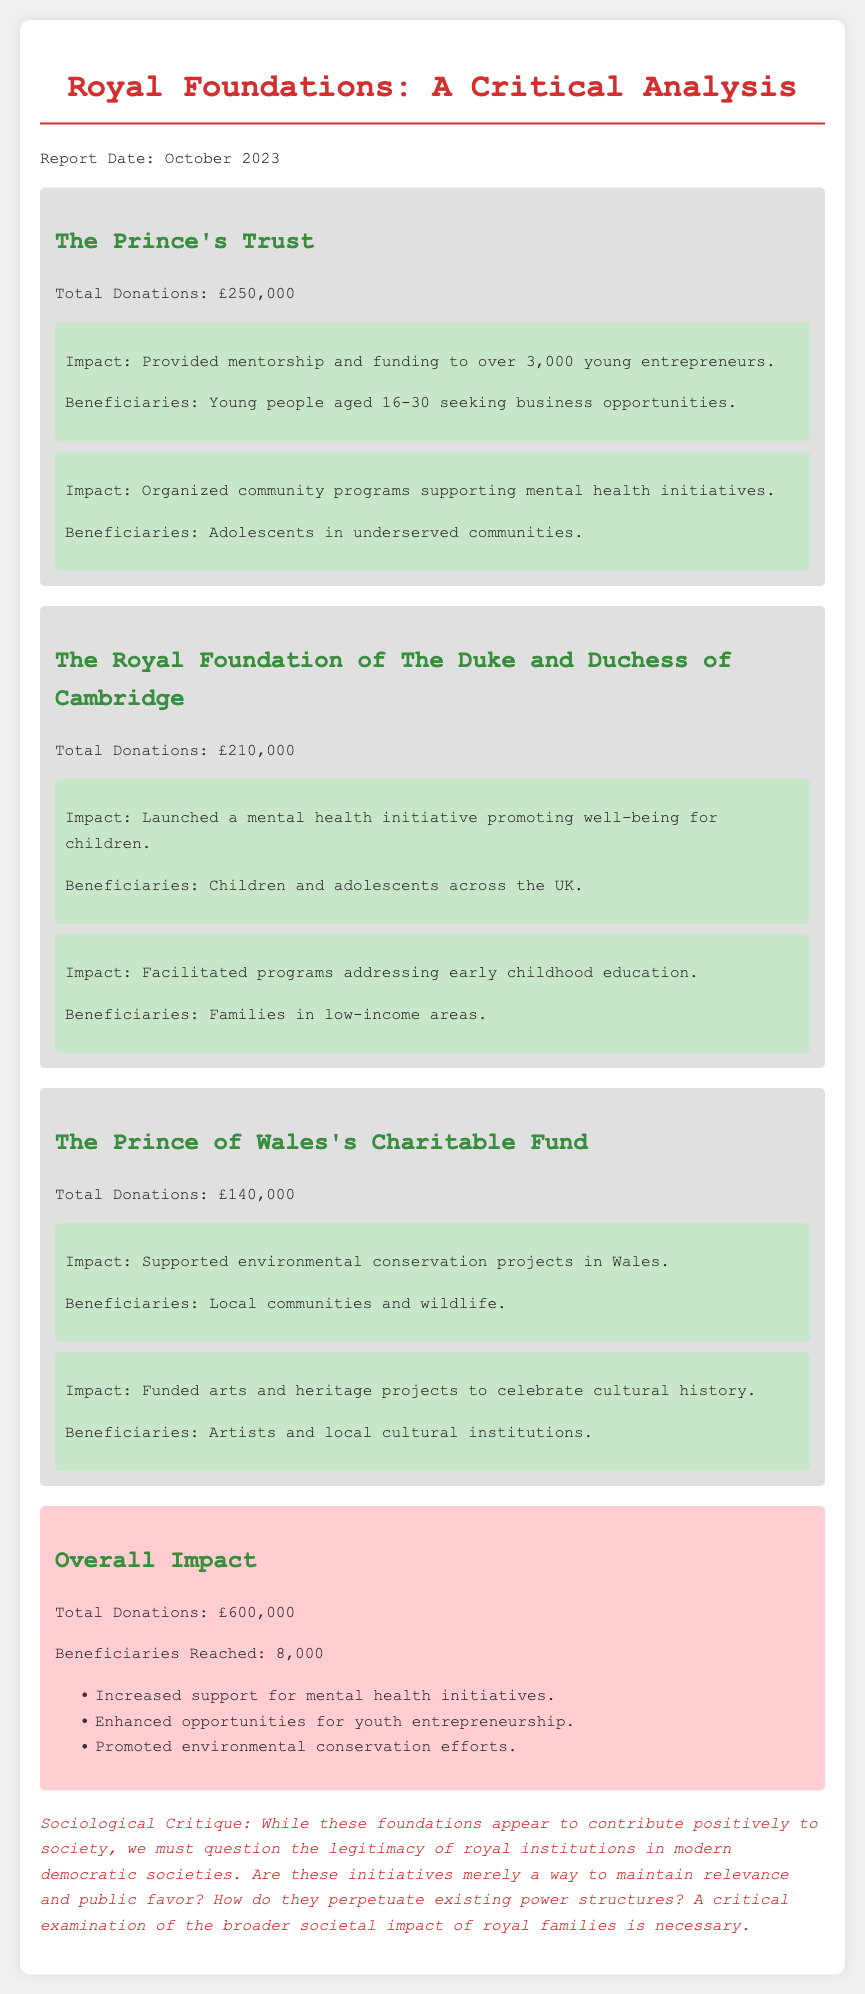What is the total amount of donations received by The Prince's Trust? The total donations are explicitly mentioned in the document for each foundation. For The Prince's Trust, it is £250,000.
Answer: £250,000 How many young entrepreneurs received mentorship from The Prince's Trust? The document states that The Prince's Trust provided mentorship and funding to over 3,000 young entrepreneurs.
Answer: over 3,000 What is the total amount of donations received by all foundations combined? The overall total donations can be calculated by adding the donations from each foundation: £250,000 + £210,000 + £140,000.
Answer: £600,000 Which mental health initiative was launched by The Royal Foundation of The Duke and Duchess of Cambridge? The document specifies that the initiative promotes well-being for children across the UK.
Answer: well-being for children Who are the beneficiaries of The Prince of Wales's Charitable Fund's environmental projects? The document indicates that the local communities and wildlife benefit from these projects.
Answer: Local communities and wildlife How many beneficiaries were reached in total by all foundations? The total number of beneficiaries reached is explicitly stated in the overall impact section of the document.
Answer: 8,000 What type of projects did The Prince of Wales's Charitable Fund support? The document mentions that the fund supported environmental conservation projects and arts and heritage projects.
Answer: Environmental conservation projects and arts and heritage projects What is the sociological critique mentioned in the document? The critique questions the legitimacy of royal institutions in modern democratic societies and suggests a need for critical examination of their societal impact.
Answer: Legitimacy of royal institutions in modern democratic societies What is the primary focus of The Royal Foundation of The Duke and Duchess of Cambridge's initiatives? The document highlights mental health and early childhood education as primary focuses of the foundation's initiatives.
Answer: Mental health and early childhood education 